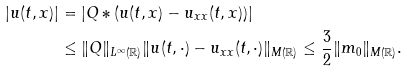<formula> <loc_0><loc_0><loc_500><loc_500>| u ( t , x ) | & = | Q \ast ( u ( t , x ) - u _ { x x } ( t , x ) ) | \\ & \leq \| Q \| _ { L ^ { \infty } ( \mathbb { R } ) } \| u ( t , \cdot ) - u _ { x x } ( t , \cdot ) \| _ { M ( \mathbb { R } ) } \leq \frac { 3 } { 2 } \| m _ { 0 } \| _ { M ( \mathbb { R } ) } .</formula> 